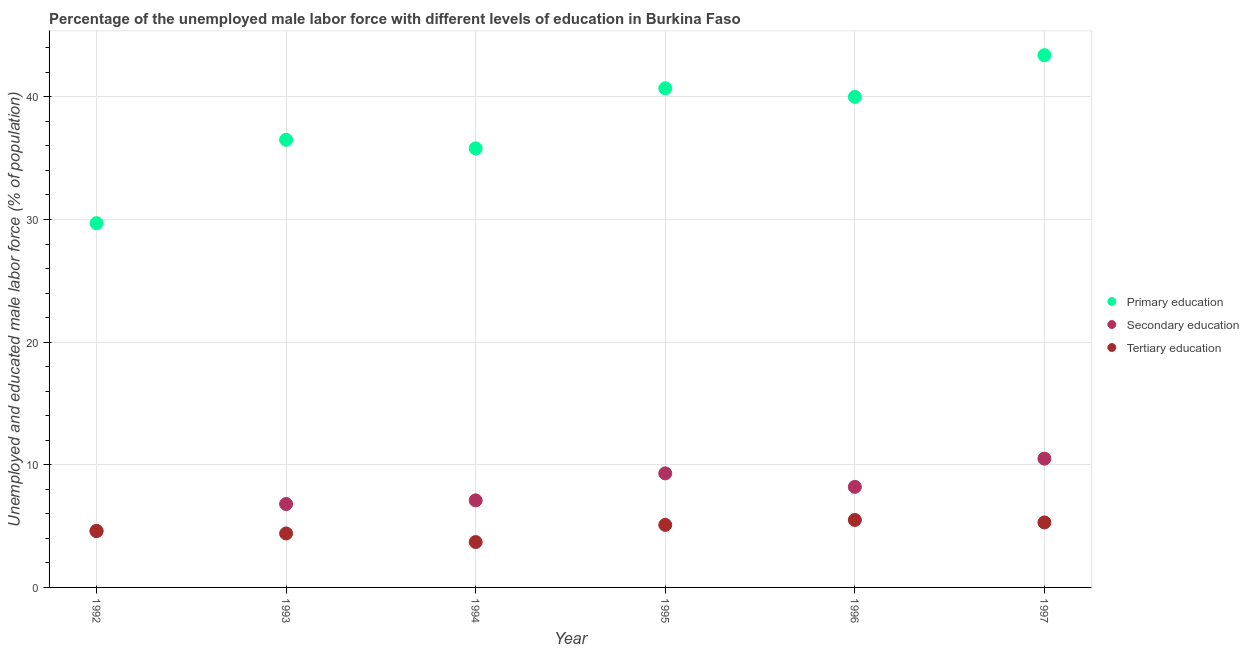What is the percentage of male labor force who received primary education in 1995?
Your response must be concise. 40.7. Across all years, what is the minimum percentage of male labor force who received primary education?
Your answer should be very brief. 29.7. What is the total percentage of male labor force who received tertiary education in the graph?
Make the answer very short. 28.6. What is the difference between the percentage of male labor force who received primary education in 1995 and that in 1996?
Provide a short and direct response. 0.7. What is the difference between the percentage of male labor force who received primary education in 1996 and the percentage of male labor force who received tertiary education in 1992?
Keep it short and to the point. 35.4. What is the average percentage of male labor force who received secondary education per year?
Provide a short and direct response. 7.75. In the year 1994, what is the difference between the percentage of male labor force who received secondary education and percentage of male labor force who received tertiary education?
Provide a short and direct response. 3.4. In how many years, is the percentage of male labor force who received secondary education greater than 34 %?
Ensure brevity in your answer.  0. What is the ratio of the percentage of male labor force who received tertiary education in 1995 to that in 1996?
Keep it short and to the point. 0.93. Is the difference between the percentage of male labor force who received tertiary education in 1993 and 1996 greater than the difference between the percentage of male labor force who received secondary education in 1993 and 1996?
Make the answer very short. Yes. What is the difference between the highest and the second highest percentage of male labor force who received primary education?
Offer a very short reply. 2.7. What is the difference between the highest and the lowest percentage of male labor force who received tertiary education?
Keep it short and to the point. 1.8. In how many years, is the percentage of male labor force who received tertiary education greater than the average percentage of male labor force who received tertiary education taken over all years?
Your response must be concise. 3. Is it the case that in every year, the sum of the percentage of male labor force who received primary education and percentage of male labor force who received secondary education is greater than the percentage of male labor force who received tertiary education?
Your answer should be compact. Yes. Does the percentage of male labor force who received secondary education monotonically increase over the years?
Your answer should be very brief. No. How many dotlines are there?
Give a very brief answer. 3. Does the graph contain any zero values?
Provide a short and direct response. No. Where does the legend appear in the graph?
Give a very brief answer. Center right. How many legend labels are there?
Your answer should be compact. 3. How are the legend labels stacked?
Make the answer very short. Vertical. What is the title of the graph?
Offer a terse response. Percentage of the unemployed male labor force with different levels of education in Burkina Faso. What is the label or title of the X-axis?
Keep it short and to the point. Year. What is the label or title of the Y-axis?
Your answer should be compact. Unemployed and educated male labor force (% of population). What is the Unemployed and educated male labor force (% of population) of Primary education in 1992?
Your response must be concise. 29.7. What is the Unemployed and educated male labor force (% of population) in Secondary education in 1992?
Offer a very short reply. 4.6. What is the Unemployed and educated male labor force (% of population) of Tertiary education in 1992?
Keep it short and to the point. 4.6. What is the Unemployed and educated male labor force (% of population) in Primary education in 1993?
Make the answer very short. 36.5. What is the Unemployed and educated male labor force (% of population) of Secondary education in 1993?
Provide a short and direct response. 6.8. What is the Unemployed and educated male labor force (% of population) in Tertiary education in 1993?
Your answer should be very brief. 4.4. What is the Unemployed and educated male labor force (% of population) in Primary education in 1994?
Your answer should be compact. 35.8. What is the Unemployed and educated male labor force (% of population) in Secondary education in 1994?
Offer a terse response. 7.1. What is the Unemployed and educated male labor force (% of population) in Tertiary education in 1994?
Offer a terse response. 3.7. What is the Unemployed and educated male labor force (% of population) of Primary education in 1995?
Offer a terse response. 40.7. What is the Unemployed and educated male labor force (% of population) in Secondary education in 1995?
Provide a short and direct response. 9.3. What is the Unemployed and educated male labor force (% of population) of Tertiary education in 1995?
Provide a succinct answer. 5.1. What is the Unemployed and educated male labor force (% of population) in Primary education in 1996?
Keep it short and to the point. 40. What is the Unemployed and educated male labor force (% of population) of Secondary education in 1996?
Provide a short and direct response. 8.2. What is the Unemployed and educated male labor force (% of population) in Tertiary education in 1996?
Offer a terse response. 5.5. What is the Unemployed and educated male labor force (% of population) in Primary education in 1997?
Make the answer very short. 43.4. What is the Unemployed and educated male labor force (% of population) of Tertiary education in 1997?
Offer a terse response. 5.3. Across all years, what is the maximum Unemployed and educated male labor force (% of population) in Primary education?
Keep it short and to the point. 43.4. Across all years, what is the maximum Unemployed and educated male labor force (% of population) in Tertiary education?
Keep it short and to the point. 5.5. Across all years, what is the minimum Unemployed and educated male labor force (% of population) of Primary education?
Offer a terse response. 29.7. Across all years, what is the minimum Unemployed and educated male labor force (% of population) in Secondary education?
Your answer should be compact. 4.6. Across all years, what is the minimum Unemployed and educated male labor force (% of population) in Tertiary education?
Give a very brief answer. 3.7. What is the total Unemployed and educated male labor force (% of population) in Primary education in the graph?
Your answer should be compact. 226.1. What is the total Unemployed and educated male labor force (% of population) of Secondary education in the graph?
Make the answer very short. 46.5. What is the total Unemployed and educated male labor force (% of population) of Tertiary education in the graph?
Your answer should be compact. 28.6. What is the difference between the Unemployed and educated male labor force (% of population) in Primary education in 1992 and that in 1993?
Your answer should be very brief. -6.8. What is the difference between the Unemployed and educated male labor force (% of population) in Tertiary education in 1992 and that in 1993?
Give a very brief answer. 0.2. What is the difference between the Unemployed and educated male labor force (% of population) in Primary education in 1992 and that in 1994?
Ensure brevity in your answer.  -6.1. What is the difference between the Unemployed and educated male labor force (% of population) of Tertiary education in 1992 and that in 1994?
Keep it short and to the point. 0.9. What is the difference between the Unemployed and educated male labor force (% of population) of Primary education in 1992 and that in 1995?
Give a very brief answer. -11. What is the difference between the Unemployed and educated male labor force (% of population) in Primary education in 1992 and that in 1997?
Ensure brevity in your answer.  -13.7. What is the difference between the Unemployed and educated male labor force (% of population) of Tertiary education in 1992 and that in 1997?
Provide a succinct answer. -0.7. What is the difference between the Unemployed and educated male labor force (% of population) of Primary education in 1993 and that in 1994?
Your response must be concise. 0.7. What is the difference between the Unemployed and educated male labor force (% of population) of Primary education in 1993 and that in 1995?
Give a very brief answer. -4.2. What is the difference between the Unemployed and educated male labor force (% of population) in Secondary education in 1993 and that in 1996?
Offer a terse response. -1.4. What is the difference between the Unemployed and educated male labor force (% of population) of Secondary education in 1993 and that in 1997?
Make the answer very short. -3.7. What is the difference between the Unemployed and educated male labor force (% of population) of Primary education in 1994 and that in 1995?
Ensure brevity in your answer.  -4.9. What is the difference between the Unemployed and educated male labor force (% of population) of Secondary education in 1994 and that in 1995?
Offer a terse response. -2.2. What is the difference between the Unemployed and educated male labor force (% of population) in Primary education in 1994 and that in 1996?
Give a very brief answer. -4.2. What is the difference between the Unemployed and educated male labor force (% of population) of Secondary education in 1994 and that in 1996?
Your answer should be very brief. -1.1. What is the difference between the Unemployed and educated male labor force (% of population) in Primary education in 1994 and that in 1997?
Provide a short and direct response. -7.6. What is the difference between the Unemployed and educated male labor force (% of population) of Secondary education in 1994 and that in 1997?
Your answer should be very brief. -3.4. What is the difference between the Unemployed and educated male labor force (% of population) in Tertiary education in 1994 and that in 1997?
Give a very brief answer. -1.6. What is the difference between the Unemployed and educated male labor force (% of population) in Primary education in 1995 and that in 1996?
Make the answer very short. 0.7. What is the difference between the Unemployed and educated male labor force (% of population) of Tertiary education in 1995 and that in 1996?
Your response must be concise. -0.4. What is the difference between the Unemployed and educated male labor force (% of population) in Primary education in 1995 and that in 1997?
Provide a succinct answer. -2.7. What is the difference between the Unemployed and educated male labor force (% of population) in Secondary education in 1995 and that in 1997?
Provide a succinct answer. -1.2. What is the difference between the Unemployed and educated male labor force (% of population) of Tertiary education in 1996 and that in 1997?
Provide a succinct answer. 0.2. What is the difference between the Unemployed and educated male labor force (% of population) in Primary education in 1992 and the Unemployed and educated male labor force (% of population) in Secondary education in 1993?
Ensure brevity in your answer.  22.9. What is the difference between the Unemployed and educated male labor force (% of population) of Primary education in 1992 and the Unemployed and educated male labor force (% of population) of Tertiary education in 1993?
Ensure brevity in your answer.  25.3. What is the difference between the Unemployed and educated male labor force (% of population) in Primary education in 1992 and the Unemployed and educated male labor force (% of population) in Secondary education in 1994?
Your answer should be compact. 22.6. What is the difference between the Unemployed and educated male labor force (% of population) of Secondary education in 1992 and the Unemployed and educated male labor force (% of population) of Tertiary education in 1994?
Your answer should be very brief. 0.9. What is the difference between the Unemployed and educated male labor force (% of population) of Primary education in 1992 and the Unemployed and educated male labor force (% of population) of Secondary education in 1995?
Provide a succinct answer. 20.4. What is the difference between the Unemployed and educated male labor force (% of population) of Primary education in 1992 and the Unemployed and educated male labor force (% of population) of Tertiary education in 1995?
Your answer should be very brief. 24.6. What is the difference between the Unemployed and educated male labor force (% of population) of Primary education in 1992 and the Unemployed and educated male labor force (% of population) of Tertiary education in 1996?
Provide a short and direct response. 24.2. What is the difference between the Unemployed and educated male labor force (% of population) in Secondary education in 1992 and the Unemployed and educated male labor force (% of population) in Tertiary education in 1996?
Offer a very short reply. -0.9. What is the difference between the Unemployed and educated male labor force (% of population) of Primary education in 1992 and the Unemployed and educated male labor force (% of population) of Secondary education in 1997?
Give a very brief answer. 19.2. What is the difference between the Unemployed and educated male labor force (% of population) in Primary education in 1992 and the Unemployed and educated male labor force (% of population) in Tertiary education in 1997?
Give a very brief answer. 24.4. What is the difference between the Unemployed and educated male labor force (% of population) in Primary education in 1993 and the Unemployed and educated male labor force (% of population) in Secondary education in 1994?
Provide a succinct answer. 29.4. What is the difference between the Unemployed and educated male labor force (% of population) of Primary education in 1993 and the Unemployed and educated male labor force (% of population) of Tertiary education in 1994?
Give a very brief answer. 32.8. What is the difference between the Unemployed and educated male labor force (% of population) of Primary education in 1993 and the Unemployed and educated male labor force (% of population) of Secondary education in 1995?
Keep it short and to the point. 27.2. What is the difference between the Unemployed and educated male labor force (% of population) in Primary education in 1993 and the Unemployed and educated male labor force (% of population) in Tertiary education in 1995?
Your answer should be very brief. 31.4. What is the difference between the Unemployed and educated male labor force (% of population) in Secondary education in 1993 and the Unemployed and educated male labor force (% of population) in Tertiary education in 1995?
Offer a terse response. 1.7. What is the difference between the Unemployed and educated male labor force (% of population) of Primary education in 1993 and the Unemployed and educated male labor force (% of population) of Secondary education in 1996?
Give a very brief answer. 28.3. What is the difference between the Unemployed and educated male labor force (% of population) of Primary education in 1993 and the Unemployed and educated male labor force (% of population) of Secondary education in 1997?
Offer a terse response. 26. What is the difference between the Unemployed and educated male labor force (% of population) of Primary education in 1993 and the Unemployed and educated male labor force (% of population) of Tertiary education in 1997?
Give a very brief answer. 31.2. What is the difference between the Unemployed and educated male labor force (% of population) of Secondary education in 1993 and the Unemployed and educated male labor force (% of population) of Tertiary education in 1997?
Your answer should be very brief. 1.5. What is the difference between the Unemployed and educated male labor force (% of population) in Primary education in 1994 and the Unemployed and educated male labor force (% of population) in Secondary education in 1995?
Offer a terse response. 26.5. What is the difference between the Unemployed and educated male labor force (% of population) of Primary education in 1994 and the Unemployed and educated male labor force (% of population) of Tertiary education in 1995?
Give a very brief answer. 30.7. What is the difference between the Unemployed and educated male labor force (% of population) in Secondary education in 1994 and the Unemployed and educated male labor force (% of population) in Tertiary education in 1995?
Keep it short and to the point. 2. What is the difference between the Unemployed and educated male labor force (% of population) of Primary education in 1994 and the Unemployed and educated male labor force (% of population) of Secondary education in 1996?
Give a very brief answer. 27.6. What is the difference between the Unemployed and educated male labor force (% of population) in Primary education in 1994 and the Unemployed and educated male labor force (% of population) in Tertiary education in 1996?
Your answer should be compact. 30.3. What is the difference between the Unemployed and educated male labor force (% of population) of Primary education in 1994 and the Unemployed and educated male labor force (% of population) of Secondary education in 1997?
Offer a terse response. 25.3. What is the difference between the Unemployed and educated male labor force (% of population) in Primary education in 1994 and the Unemployed and educated male labor force (% of population) in Tertiary education in 1997?
Your answer should be very brief. 30.5. What is the difference between the Unemployed and educated male labor force (% of population) of Secondary education in 1994 and the Unemployed and educated male labor force (% of population) of Tertiary education in 1997?
Make the answer very short. 1.8. What is the difference between the Unemployed and educated male labor force (% of population) in Primary education in 1995 and the Unemployed and educated male labor force (% of population) in Secondary education in 1996?
Your response must be concise. 32.5. What is the difference between the Unemployed and educated male labor force (% of population) of Primary education in 1995 and the Unemployed and educated male labor force (% of population) of Tertiary education in 1996?
Make the answer very short. 35.2. What is the difference between the Unemployed and educated male labor force (% of population) in Primary education in 1995 and the Unemployed and educated male labor force (% of population) in Secondary education in 1997?
Offer a very short reply. 30.2. What is the difference between the Unemployed and educated male labor force (% of population) of Primary education in 1995 and the Unemployed and educated male labor force (% of population) of Tertiary education in 1997?
Provide a short and direct response. 35.4. What is the difference between the Unemployed and educated male labor force (% of population) of Secondary education in 1995 and the Unemployed and educated male labor force (% of population) of Tertiary education in 1997?
Keep it short and to the point. 4. What is the difference between the Unemployed and educated male labor force (% of population) in Primary education in 1996 and the Unemployed and educated male labor force (% of population) in Secondary education in 1997?
Your answer should be compact. 29.5. What is the difference between the Unemployed and educated male labor force (% of population) in Primary education in 1996 and the Unemployed and educated male labor force (% of population) in Tertiary education in 1997?
Your answer should be very brief. 34.7. What is the difference between the Unemployed and educated male labor force (% of population) of Secondary education in 1996 and the Unemployed and educated male labor force (% of population) of Tertiary education in 1997?
Your answer should be compact. 2.9. What is the average Unemployed and educated male labor force (% of population) in Primary education per year?
Ensure brevity in your answer.  37.68. What is the average Unemployed and educated male labor force (% of population) in Secondary education per year?
Your answer should be compact. 7.75. What is the average Unemployed and educated male labor force (% of population) of Tertiary education per year?
Your answer should be compact. 4.77. In the year 1992, what is the difference between the Unemployed and educated male labor force (% of population) of Primary education and Unemployed and educated male labor force (% of population) of Secondary education?
Your answer should be very brief. 25.1. In the year 1992, what is the difference between the Unemployed and educated male labor force (% of population) in Primary education and Unemployed and educated male labor force (% of population) in Tertiary education?
Give a very brief answer. 25.1. In the year 1992, what is the difference between the Unemployed and educated male labor force (% of population) in Secondary education and Unemployed and educated male labor force (% of population) in Tertiary education?
Your response must be concise. 0. In the year 1993, what is the difference between the Unemployed and educated male labor force (% of population) of Primary education and Unemployed and educated male labor force (% of population) of Secondary education?
Your answer should be very brief. 29.7. In the year 1993, what is the difference between the Unemployed and educated male labor force (% of population) of Primary education and Unemployed and educated male labor force (% of population) of Tertiary education?
Make the answer very short. 32.1. In the year 1993, what is the difference between the Unemployed and educated male labor force (% of population) of Secondary education and Unemployed and educated male labor force (% of population) of Tertiary education?
Give a very brief answer. 2.4. In the year 1994, what is the difference between the Unemployed and educated male labor force (% of population) of Primary education and Unemployed and educated male labor force (% of population) of Secondary education?
Keep it short and to the point. 28.7. In the year 1994, what is the difference between the Unemployed and educated male labor force (% of population) of Primary education and Unemployed and educated male labor force (% of population) of Tertiary education?
Your response must be concise. 32.1. In the year 1994, what is the difference between the Unemployed and educated male labor force (% of population) of Secondary education and Unemployed and educated male labor force (% of population) of Tertiary education?
Your answer should be very brief. 3.4. In the year 1995, what is the difference between the Unemployed and educated male labor force (% of population) of Primary education and Unemployed and educated male labor force (% of population) of Secondary education?
Ensure brevity in your answer.  31.4. In the year 1995, what is the difference between the Unemployed and educated male labor force (% of population) of Primary education and Unemployed and educated male labor force (% of population) of Tertiary education?
Make the answer very short. 35.6. In the year 1995, what is the difference between the Unemployed and educated male labor force (% of population) of Secondary education and Unemployed and educated male labor force (% of population) of Tertiary education?
Provide a succinct answer. 4.2. In the year 1996, what is the difference between the Unemployed and educated male labor force (% of population) in Primary education and Unemployed and educated male labor force (% of population) in Secondary education?
Offer a terse response. 31.8. In the year 1996, what is the difference between the Unemployed and educated male labor force (% of population) of Primary education and Unemployed and educated male labor force (% of population) of Tertiary education?
Ensure brevity in your answer.  34.5. In the year 1997, what is the difference between the Unemployed and educated male labor force (% of population) of Primary education and Unemployed and educated male labor force (% of population) of Secondary education?
Offer a terse response. 32.9. In the year 1997, what is the difference between the Unemployed and educated male labor force (% of population) in Primary education and Unemployed and educated male labor force (% of population) in Tertiary education?
Make the answer very short. 38.1. What is the ratio of the Unemployed and educated male labor force (% of population) in Primary education in 1992 to that in 1993?
Give a very brief answer. 0.81. What is the ratio of the Unemployed and educated male labor force (% of population) in Secondary education in 1992 to that in 1993?
Make the answer very short. 0.68. What is the ratio of the Unemployed and educated male labor force (% of population) of Tertiary education in 1992 to that in 1993?
Your answer should be compact. 1.05. What is the ratio of the Unemployed and educated male labor force (% of population) in Primary education in 1992 to that in 1994?
Your answer should be compact. 0.83. What is the ratio of the Unemployed and educated male labor force (% of population) in Secondary education in 1992 to that in 1994?
Your answer should be very brief. 0.65. What is the ratio of the Unemployed and educated male labor force (% of population) of Tertiary education in 1992 to that in 1994?
Offer a terse response. 1.24. What is the ratio of the Unemployed and educated male labor force (% of population) of Primary education in 1992 to that in 1995?
Your answer should be very brief. 0.73. What is the ratio of the Unemployed and educated male labor force (% of population) in Secondary education in 1992 to that in 1995?
Your answer should be very brief. 0.49. What is the ratio of the Unemployed and educated male labor force (% of population) of Tertiary education in 1992 to that in 1995?
Give a very brief answer. 0.9. What is the ratio of the Unemployed and educated male labor force (% of population) in Primary education in 1992 to that in 1996?
Keep it short and to the point. 0.74. What is the ratio of the Unemployed and educated male labor force (% of population) in Secondary education in 1992 to that in 1996?
Keep it short and to the point. 0.56. What is the ratio of the Unemployed and educated male labor force (% of population) in Tertiary education in 1992 to that in 1996?
Keep it short and to the point. 0.84. What is the ratio of the Unemployed and educated male labor force (% of population) of Primary education in 1992 to that in 1997?
Offer a terse response. 0.68. What is the ratio of the Unemployed and educated male labor force (% of population) of Secondary education in 1992 to that in 1997?
Provide a succinct answer. 0.44. What is the ratio of the Unemployed and educated male labor force (% of population) of Tertiary education in 1992 to that in 1997?
Your answer should be very brief. 0.87. What is the ratio of the Unemployed and educated male labor force (% of population) in Primary education in 1993 to that in 1994?
Offer a terse response. 1.02. What is the ratio of the Unemployed and educated male labor force (% of population) of Secondary education in 1993 to that in 1994?
Your answer should be very brief. 0.96. What is the ratio of the Unemployed and educated male labor force (% of population) of Tertiary education in 1993 to that in 1994?
Ensure brevity in your answer.  1.19. What is the ratio of the Unemployed and educated male labor force (% of population) of Primary education in 1993 to that in 1995?
Make the answer very short. 0.9. What is the ratio of the Unemployed and educated male labor force (% of population) in Secondary education in 1993 to that in 1995?
Make the answer very short. 0.73. What is the ratio of the Unemployed and educated male labor force (% of population) of Tertiary education in 1993 to that in 1995?
Provide a short and direct response. 0.86. What is the ratio of the Unemployed and educated male labor force (% of population) of Primary education in 1993 to that in 1996?
Make the answer very short. 0.91. What is the ratio of the Unemployed and educated male labor force (% of population) in Secondary education in 1993 to that in 1996?
Make the answer very short. 0.83. What is the ratio of the Unemployed and educated male labor force (% of population) of Primary education in 1993 to that in 1997?
Your answer should be compact. 0.84. What is the ratio of the Unemployed and educated male labor force (% of population) in Secondary education in 1993 to that in 1997?
Provide a short and direct response. 0.65. What is the ratio of the Unemployed and educated male labor force (% of population) of Tertiary education in 1993 to that in 1997?
Ensure brevity in your answer.  0.83. What is the ratio of the Unemployed and educated male labor force (% of population) in Primary education in 1994 to that in 1995?
Your answer should be compact. 0.88. What is the ratio of the Unemployed and educated male labor force (% of population) in Secondary education in 1994 to that in 1995?
Your answer should be very brief. 0.76. What is the ratio of the Unemployed and educated male labor force (% of population) in Tertiary education in 1994 to that in 1995?
Ensure brevity in your answer.  0.73. What is the ratio of the Unemployed and educated male labor force (% of population) of Primary education in 1994 to that in 1996?
Give a very brief answer. 0.9. What is the ratio of the Unemployed and educated male labor force (% of population) in Secondary education in 1994 to that in 1996?
Your answer should be very brief. 0.87. What is the ratio of the Unemployed and educated male labor force (% of population) of Tertiary education in 1994 to that in 1996?
Give a very brief answer. 0.67. What is the ratio of the Unemployed and educated male labor force (% of population) in Primary education in 1994 to that in 1997?
Provide a short and direct response. 0.82. What is the ratio of the Unemployed and educated male labor force (% of population) of Secondary education in 1994 to that in 1997?
Provide a short and direct response. 0.68. What is the ratio of the Unemployed and educated male labor force (% of population) of Tertiary education in 1994 to that in 1997?
Provide a short and direct response. 0.7. What is the ratio of the Unemployed and educated male labor force (% of population) of Primary education in 1995 to that in 1996?
Provide a succinct answer. 1.02. What is the ratio of the Unemployed and educated male labor force (% of population) in Secondary education in 1995 to that in 1996?
Provide a succinct answer. 1.13. What is the ratio of the Unemployed and educated male labor force (% of population) of Tertiary education in 1995 to that in 1996?
Provide a succinct answer. 0.93. What is the ratio of the Unemployed and educated male labor force (% of population) of Primary education in 1995 to that in 1997?
Offer a terse response. 0.94. What is the ratio of the Unemployed and educated male labor force (% of population) of Secondary education in 1995 to that in 1997?
Give a very brief answer. 0.89. What is the ratio of the Unemployed and educated male labor force (% of population) in Tertiary education in 1995 to that in 1997?
Your answer should be compact. 0.96. What is the ratio of the Unemployed and educated male labor force (% of population) of Primary education in 1996 to that in 1997?
Provide a succinct answer. 0.92. What is the ratio of the Unemployed and educated male labor force (% of population) of Secondary education in 1996 to that in 1997?
Provide a short and direct response. 0.78. What is the ratio of the Unemployed and educated male labor force (% of population) of Tertiary education in 1996 to that in 1997?
Offer a terse response. 1.04. What is the difference between the highest and the second highest Unemployed and educated male labor force (% of population) in Secondary education?
Give a very brief answer. 1.2. What is the difference between the highest and the lowest Unemployed and educated male labor force (% of population) of Primary education?
Ensure brevity in your answer.  13.7. What is the difference between the highest and the lowest Unemployed and educated male labor force (% of population) of Tertiary education?
Provide a succinct answer. 1.8. 